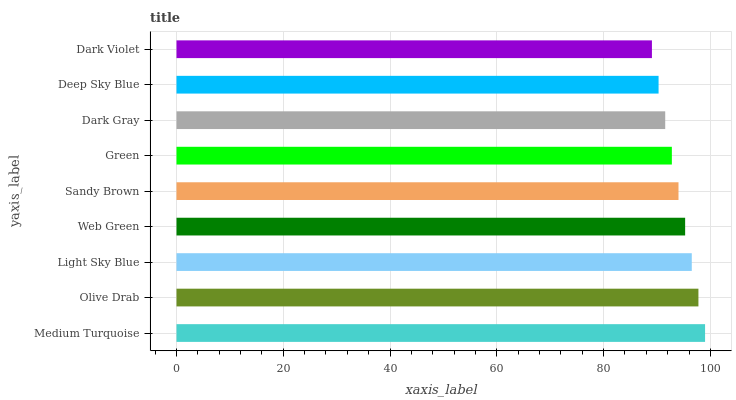Is Dark Violet the minimum?
Answer yes or no. Yes. Is Medium Turquoise the maximum?
Answer yes or no. Yes. Is Olive Drab the minimum?
Answer yes or no. No. Is Olive Drab the maximum?
Answer yes or no. No. Is Medium Turquoise greater than Olive Drab?
Answer yes or no. Yes. Is Olive Drab less than Medium Turquoise?
Answer yes or no. Yes. Is Olive Drab greater than Medium Turquoise?
Answer yes or no. No. Is Medium Turquoise less than Olive Drab?
Answer yes or no. No. Is Sandy Brown the high median?
Answer yes or no. Yes. Is Sandy Brown the low median?
Answer yes or no. Yes. Is Dark Violet the high median?
Answer yes or no. No. Is Olive Drab the low median?
Answer yes or no. No. 